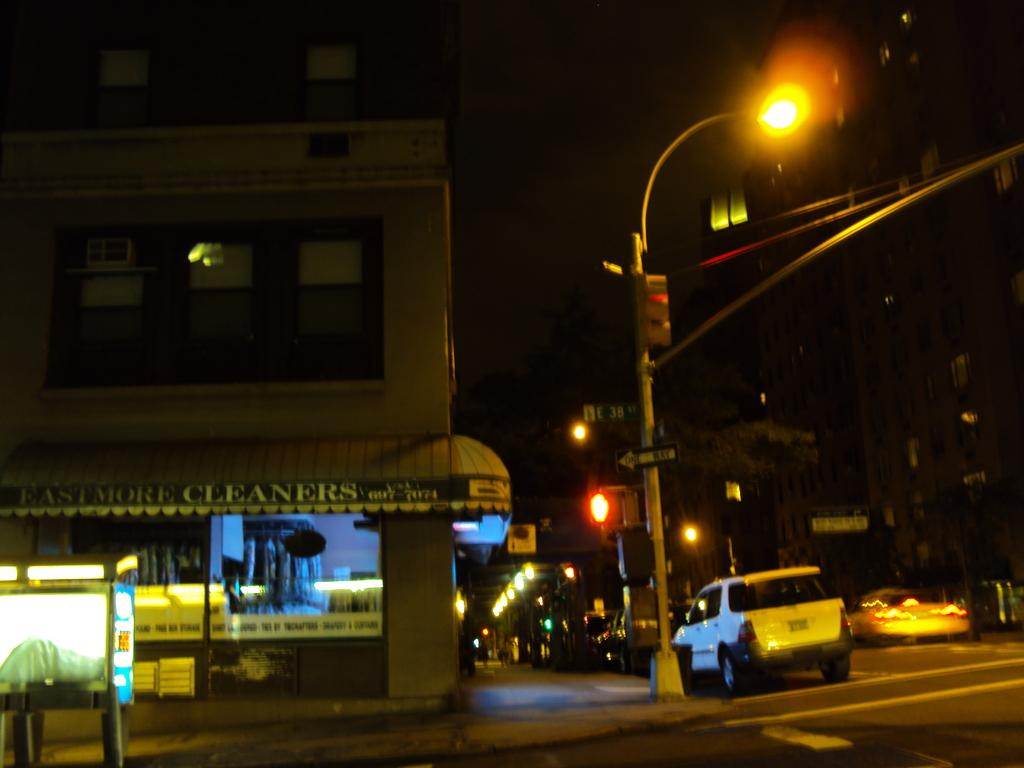Provide a one-sentence caption for the provided image. A dark intersection at night with a shop on the corner called Eastmore Cleaners. 